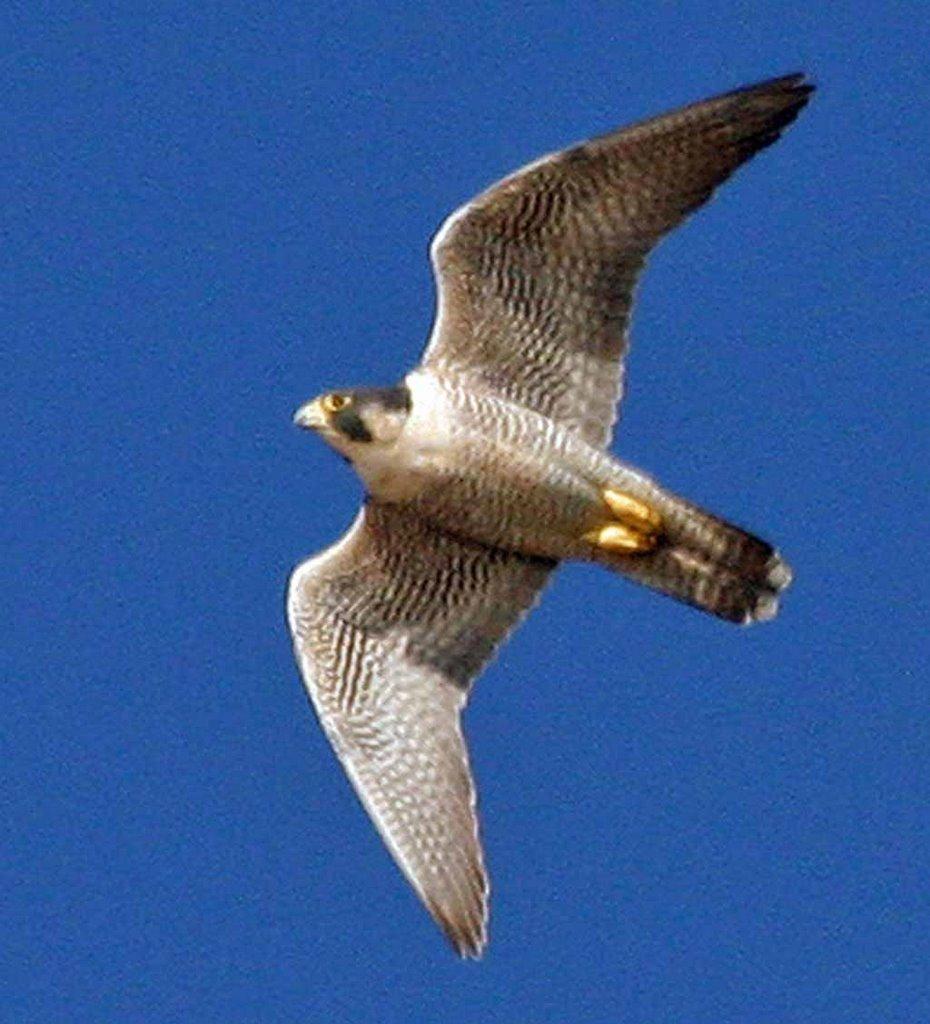Describe this image in one or two sentences. In this image there is an eagle. 